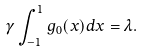Convert formula to latex. <formula><loc_0><loc_0><loc_500><loc_500>\gamma \int _ { - 1 } ^ { 1 } g _ { 0 } ( x ) d x = \lambda .</formula> 